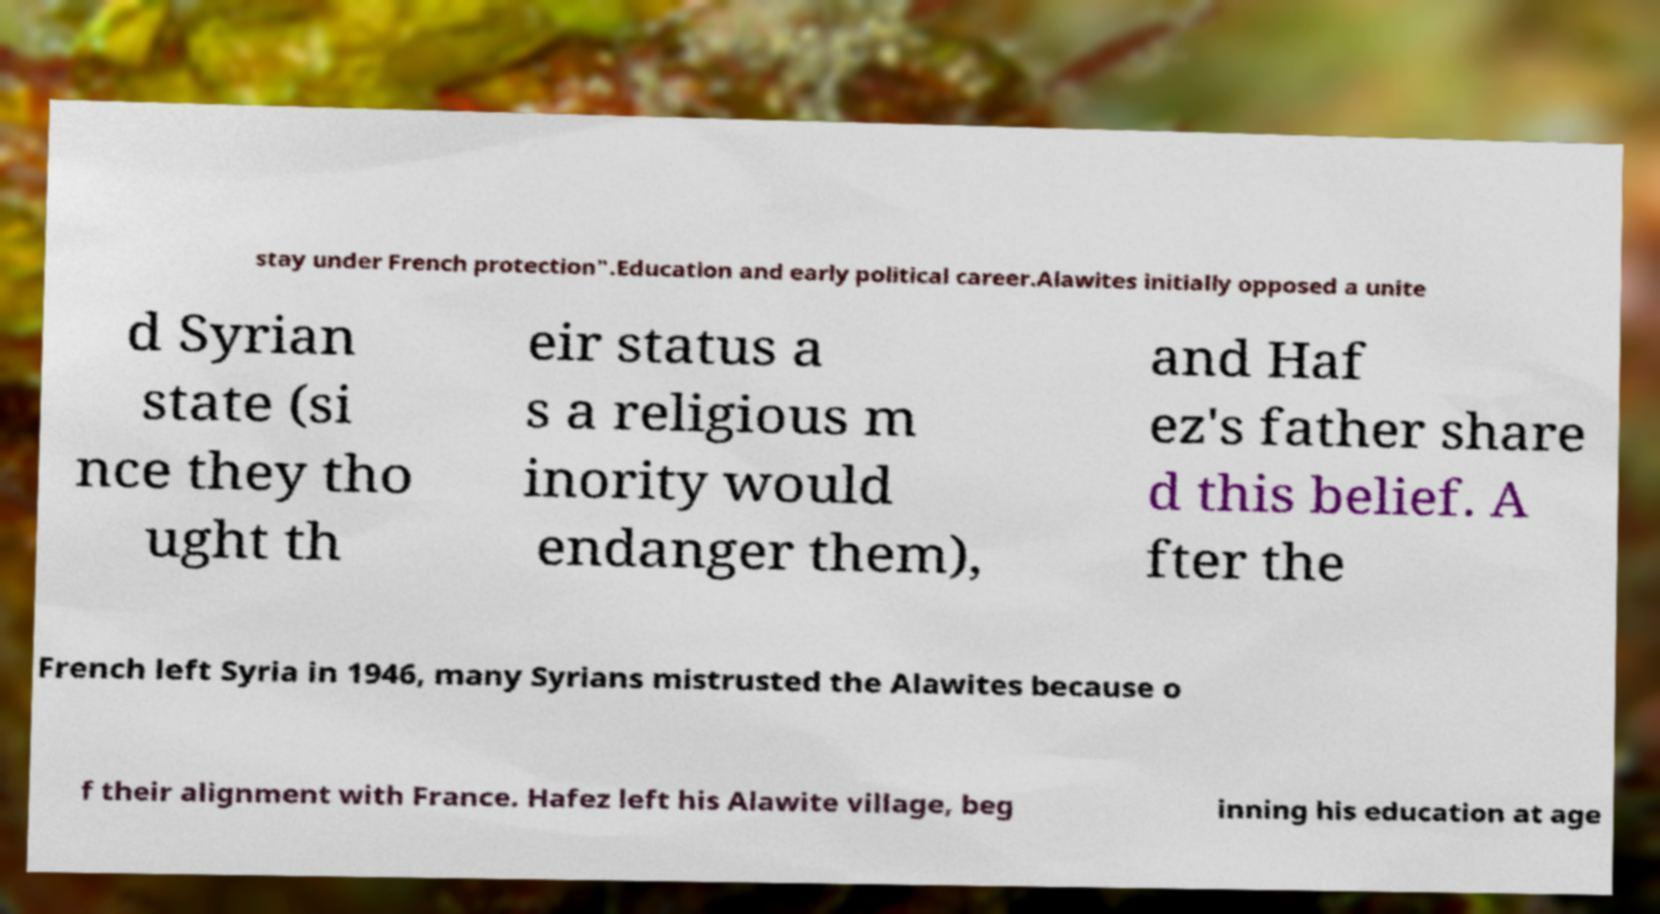Can you accurately transcribe the text from the provided image for me? stay under French protection".Education and early political career.Alawites initially opposed a unite d Syrian state (si nce they tho ught th eir status a s a religious m inority would endanger them), and Haf ez's father share d this belief. A fter the French left Syria in 1946, many Syrians mistrusted the Alawites because o f their alignment with France. Hafez left his Alawite village, beg inning his education at age 